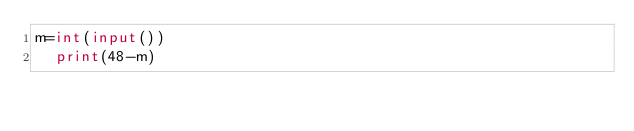Convert code to text. <code><loc_0><loc_0><loc_500><loc_500><_Python_>m=int(input())
  print(48-m)</code> 